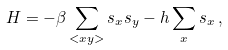Convert formula to latex. <formula><loc_0><loc_0><loc_500><loc_500>H = - \beta \sum _ { < x y > } s _ { x } s _ { y } - h \sum _ { x } s _ { x } \, ,</formula> 